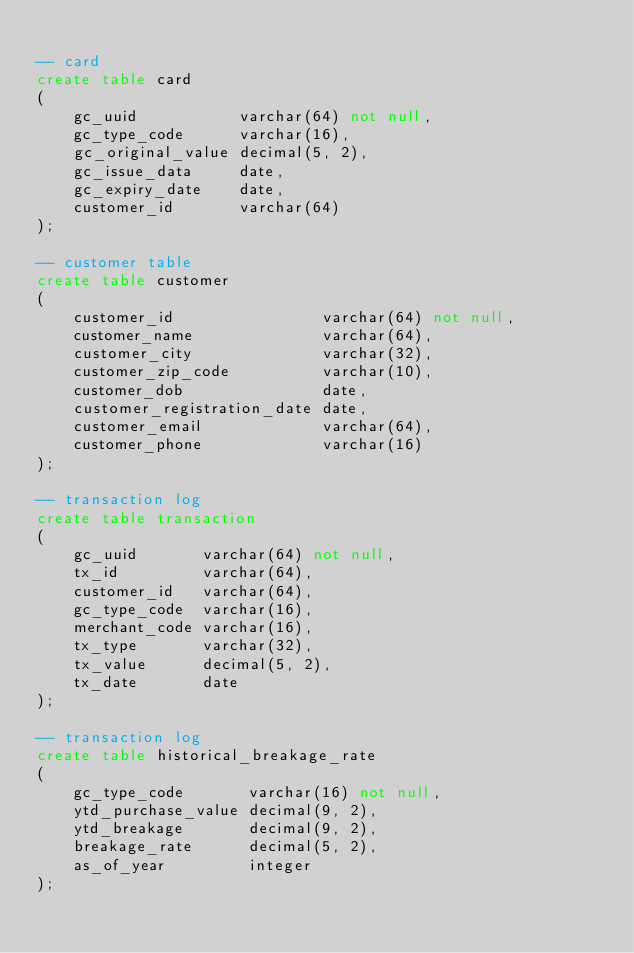<code> <loc_0><loc_0><loc_500><loc_500><_SQL_>
-- card
create table card
(
    gc_uuid           varchar(64) not null,
    gc_type_code      varchar(16),
    gc_original_value decimal(5, 2),
    gc_issue_data     date,
    gc_expiry_date    date,
    customer_id       varchar(64)
);

-- customer table
create table customer
(
    customer_id                varchar(64) not null,
    customer_name              varchar(64),
    customer_city              varchar(32),
    customer_zip_code          varchar(10),
    customer_dob               date,
    customer_registration_date date,
    customer_email             varchar(64),
    customer_phone             varchar(16)
);

-- transaction log
create table transaction
(
    gc_uuid       varchar(64) not null,
    tx_id         varchar(64),
    customer_id   varchar(64),
    gc_type_code  varchar(16),
    merchant_code varchar(16),
    tx_type       varchar(32),
    tx_value      decimal(5, 2),
    tx_date       date
);

-- transaction log
create table historical_breakage_rate
(
    gc_type_code       varchar(16) not null,
    ytd_purchase_value decimal(9, 2),
    ytd_breakage       decimal(9, 2),
    breakage_rate      decimal(5, 2),
    as_of_year         integer
);</code> 